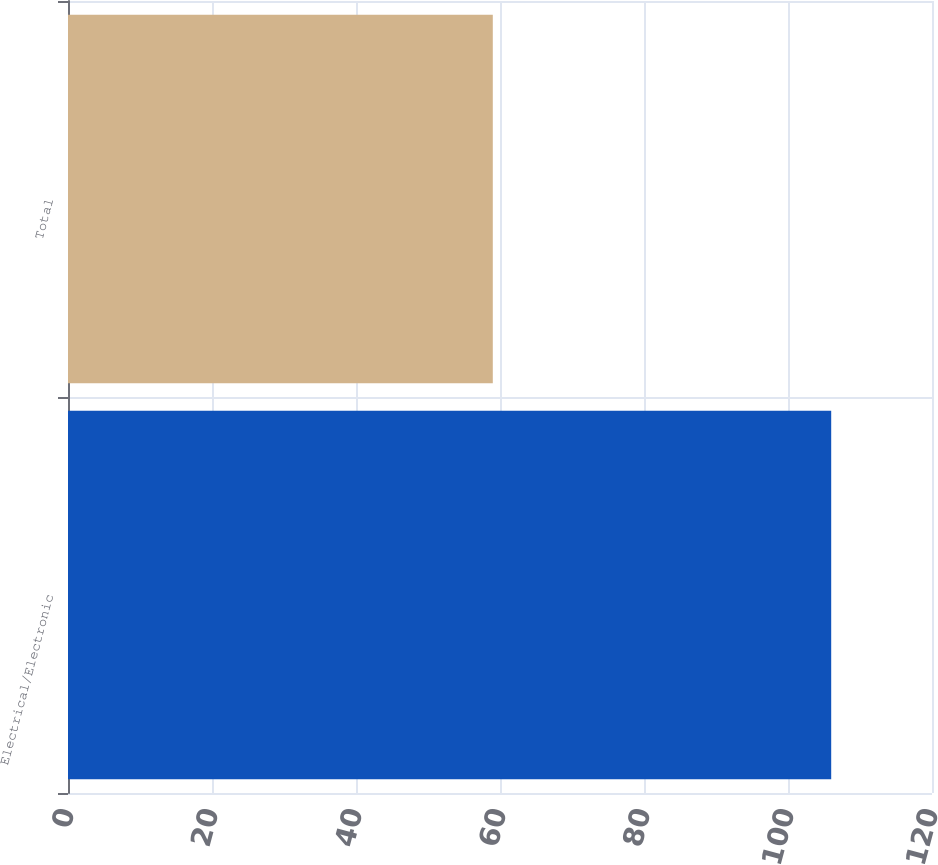<chart> <loc_0><loc_0><loc_500><loc_500><bar_chart><fcel>Electrical/Electronic<fcel>Total<nl><fcel>106<fcel>59<nl></chart> 